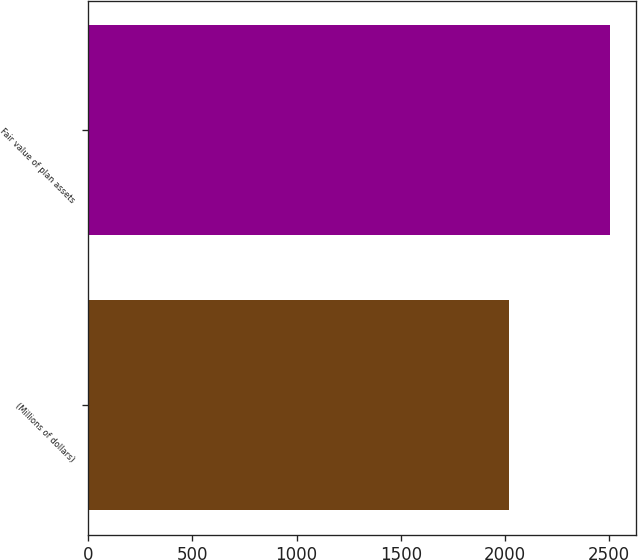Convert chart to OTSL. <chart><loc_0><loc_0><loc_500><loc_500><bar_chart><fcel>(Millions of dollars)<fcel>Fair value of plan assets<nl><fcel>2018<fcel>2502<nl></chart> 